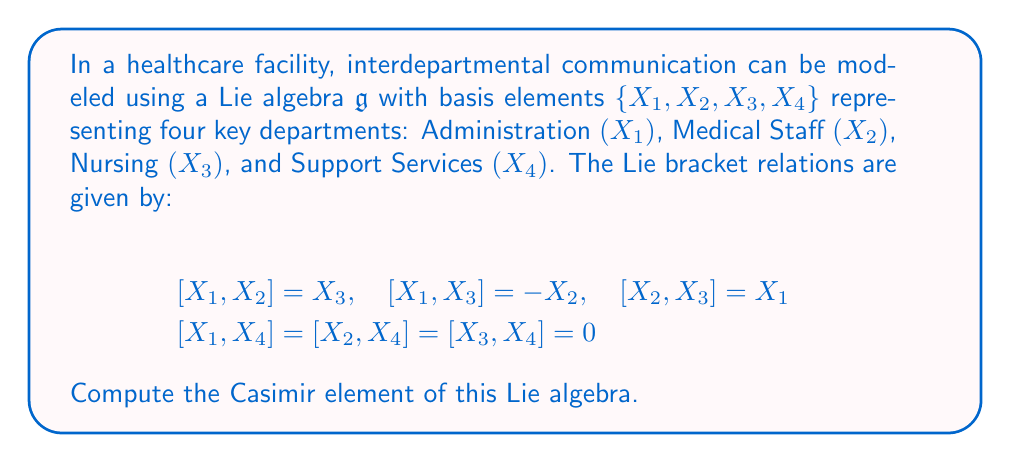Teach me how to tackle this problem. To compute the Casimir element, we'll follow these steps:

1) First, we need to find the Killing form $B(X,Y) = \text{tr}(\text{ad}_X \circ \text{ad}_Y)$ for this Lie algebra.

2) For each basis element $X_i$, we'll compute the matrix of $\text{ad}_{X_i}$ with respect to the given basis.

3) We'll use these matrices to calculate the Killing form for each pair of basis elements.

4) Once we have the Killing form, we'll find its inverse matrix.

5) Finally, we'll express the Casimir element using the inverse of the Killing form.

Step 1: Computing $\text{ad}_{X_i}$ matrices

For $X_1$:
$$\text{ad}_{X_1} = \begin{pmatrix}
0 & 0 & 0 & 0 \\
0 & 0 & -1 & 0 \\
0 & 1 & 0 & 0 \\
0 & 0 & 0 & 0
\end{pmatrix}$$

For $X_2$:
$$\text{ad}_{X_2} = \begin{pmatrix}
0 & 0 & 1 & 0 \\
0 & 0 & 0 & 0 \\
-1 & 0 & 0 & 0 \\
0 & 0 & 0 & 0
\end{pmatrix}$$

For $X_3$:
$$\text{ad}_{X_3} = \begin{pmatrix}
0 & -1 & 0 & 0 \\
1 & 0 & 0 & 0 \\
0 & 0 & 0 & 0 \\
0 & 0 & 0 & 0
\end{pmatrix}$$

For $X_4$:
$$\text{ad}_{X_4} = \begin{pmatrix}
0 & 0 & 0 & 0 \\
0 & 0 & 0 & 0 \\
0 & 0 & 0 & 0 \\
0 & 0 & 0 & 0
\end{pmatrix}$$

Step 2: Computing the Killing form

$B(X_i, X_j) = \text{tr}(\text{ad}_{X_i} \circ \text{ad}_{X_j})$

$B(X_1, X_1) = B(X_2, X_2) = B(X_3, X_3) = -2$
$B(X_1, X_2) = B(X_2, X_1) = B(X_1, X_3) = B(X_3, X_1) = B(X_2, X_3) = B(X_3, X_2) = 0$
$B(X_4, X_4) = B(X_1, X_4) = B(X_2, X_4) = B(X_3, X_4) = 0$

The Killing form matrix is:
$$B = \begin{pmatrix}
-2 & 0 & 0 & 0 \\
0 & -2 & 0 & 0 \\
0 & 0 & -2 & 0 \\
0 & 0 & 0 & 0
\end{pmatrix}$$

Step 3: Finding the inverse of the Killing form

The inverse of $B$ is:
$$B^{-1} = \begin{pmatrix}
-1/2 & 0 & 0 & 0 \\
0 & -1/2 & 0 & 0 \\
0 & 0 & -1/2 & 0 \\
0 & 0 & 0 & 0
\end{pmatrix}$$

Step 4: Expressing the Casimir element

The Casimir element $C$ is given by:
$$C = \sum_{i,j} B^{ij} X_i X_j$$

where $B^{ij}$ are the entries of $B^{-1}$.

Therefore, the Casimir element is:
$$C = -\frac{1}{2}(X_1^2 + X_2^2 + X_3^2)$$
Answer: The Casimir element of the given Lie algebra is:
$$C = -\frac{1}{2}(X_1^2 + X_2^2 + X_3^2)$$ 